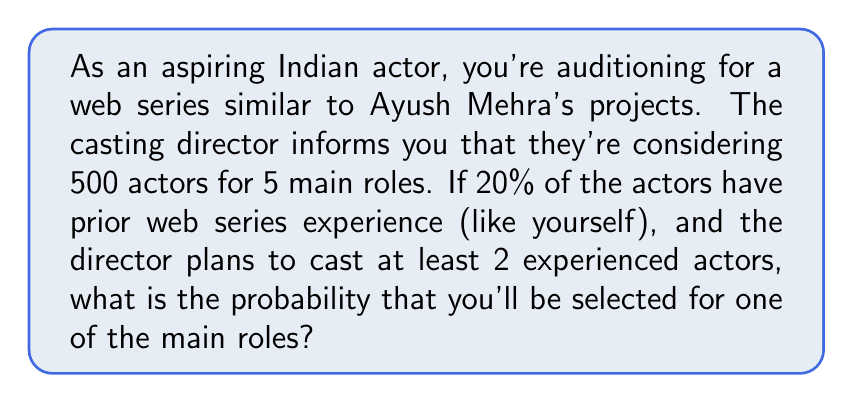Could you help me with this problem? Let's approach this step-by-step:

1) First, let's identify the given information:
   - Total number of actors auditioning: 500
   - Number of main roles: 5
   - Percentage of actors with experience: 20%
   - Number of experienced actors to be cast: at least 2

2) Calculate the number of experienced actors:
   $500 \times 20\% = 100$ experienced actors

3) We need to calculate the probability of being selected given that you're in the experienced group. This is a hypergeometric distribution problem.

4) The possible scenarios are:
   - 2 experienced actors selected out of 5
   - 3 experienced actors selected out of 5
   - 4 experienced actors selected out of 5
   - 5 experienced actors selected out of 5

5) Let's calculate the probability for each scenario:

   $P(\text{selected}) = \frac{\text{favorable outcomes}}{\text{total outcomes}}$

   $P(\text{2 exp}) = \frac{\binom{100}{2} \binom{400}{3}}{\binom{500}{5}} \times \frac{2}{100}$
   
   $P(\text{3 exp}) = \frac{\binom{100}{3} \binom{400}{2}}{\binom{500}{5}} \times \frac{3}{100}$
   
   $P(\text{4 exp}) = \frac{\binom{100}{4} \binom{400}{1}}{\binom{500}{5}} \times \frac{4}{100}$
   
   $P(\text{5 exp}) = \frac{\binom{100}{5} \binom{400}{0}}{\binom{500}{5}} \times \frac{5}{100}$

6) Sum up all these probabilities:

   $P(\text{total}) = P(\text{2 exp}) + P(\text{3 exp}) + P(\text{4 exp}) + P(\text{5 exp})$

7) Calculating this (you may use a calculator):

   $P(\text{total}) \approx 0.0099 + 0.0059 + 0.0012 + 0.0001 = 0.0171$
Answer: The probability of being selected for one of the main roles is approximately 0.0171 or 1.71%. 